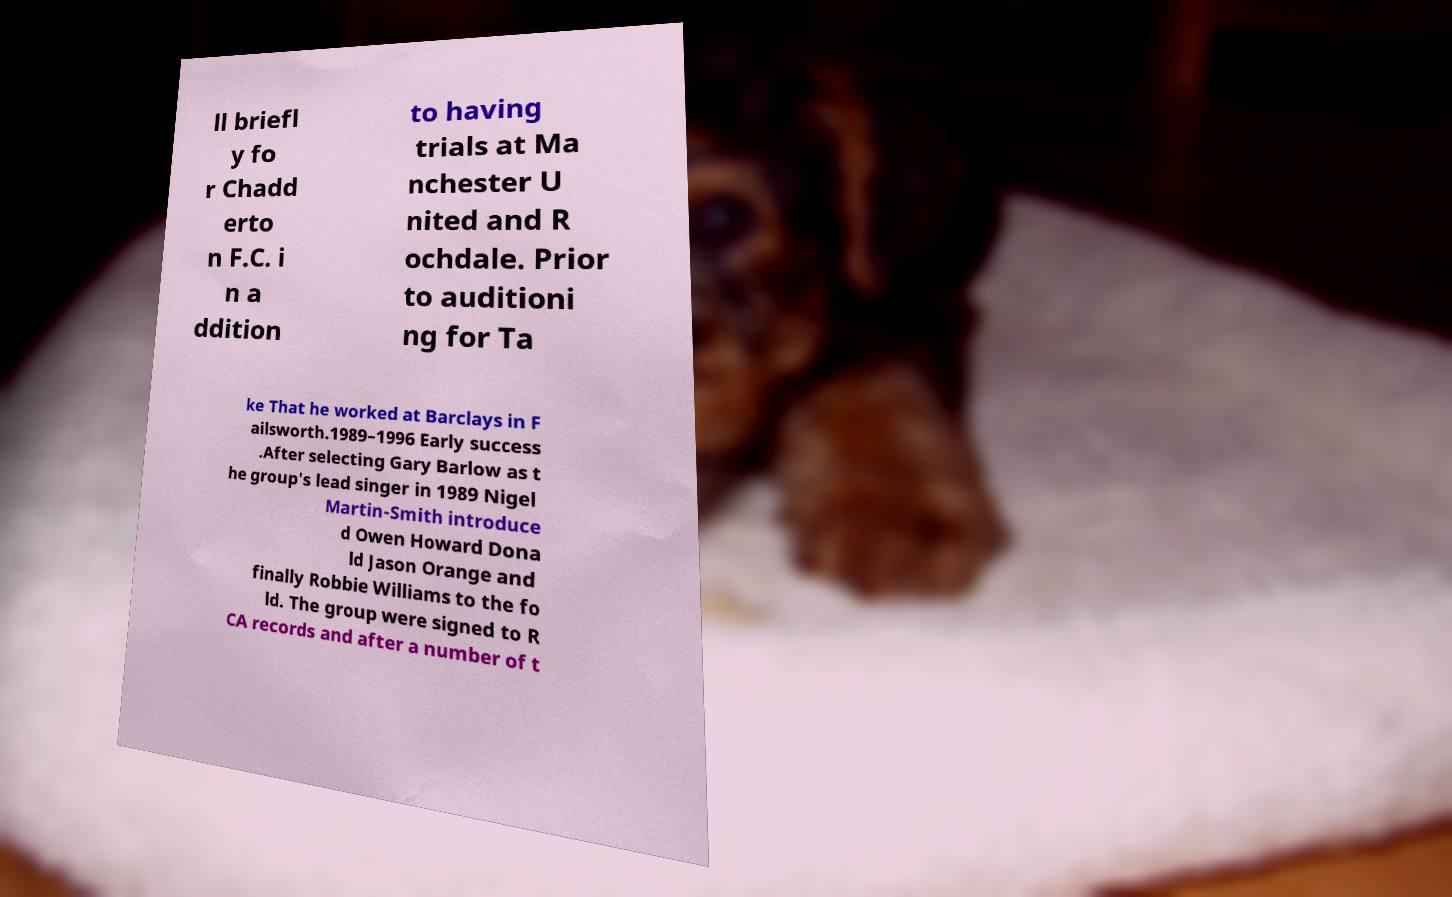What messages or text are displayed in this image? I need them in a readable, typed format. ll briefl y fo r Chadd erto n F.C. i n a ddition to having trials at Ma nchester U nited and R ochdale. Prior to auditioni ng for Ta ke That he worked at Barclays in F ailsworth.1989–1996 Early success .After selecting Gary Barlow as t he group's lead singer in 1989 Nigel Martin-Smith introduce d Owen Howard Dona ld Jason Orange and finally Robbie Williams to the fo ld. The group were signed to R CA records and after a number of t 